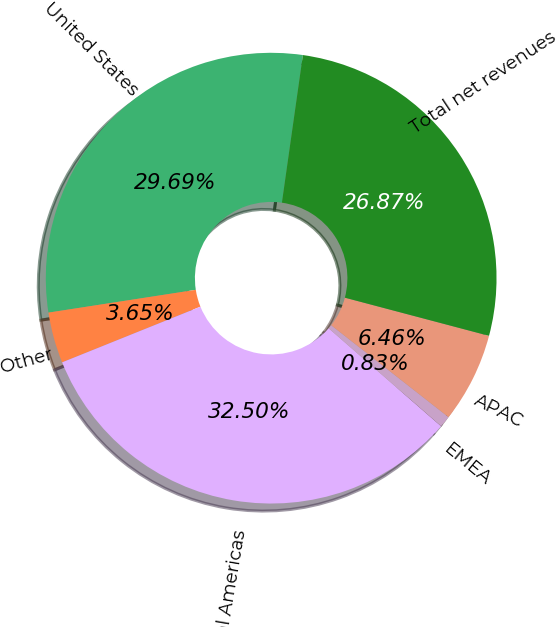Convert chart to OTSL. <chart><loc_0><loc_0><loc_500><loc_500><pie_chart><fcel>United States<fcel>Other<fcel>Total Americas<fcel>EMEA<fcel>APAC<fcel>Total net revenues<nl><fcel>29.69%<fcel>3.65%<fcel>32.5%<fcel>0.83%<fcel>6.46%<fcel>26.87%<nl></chart> 